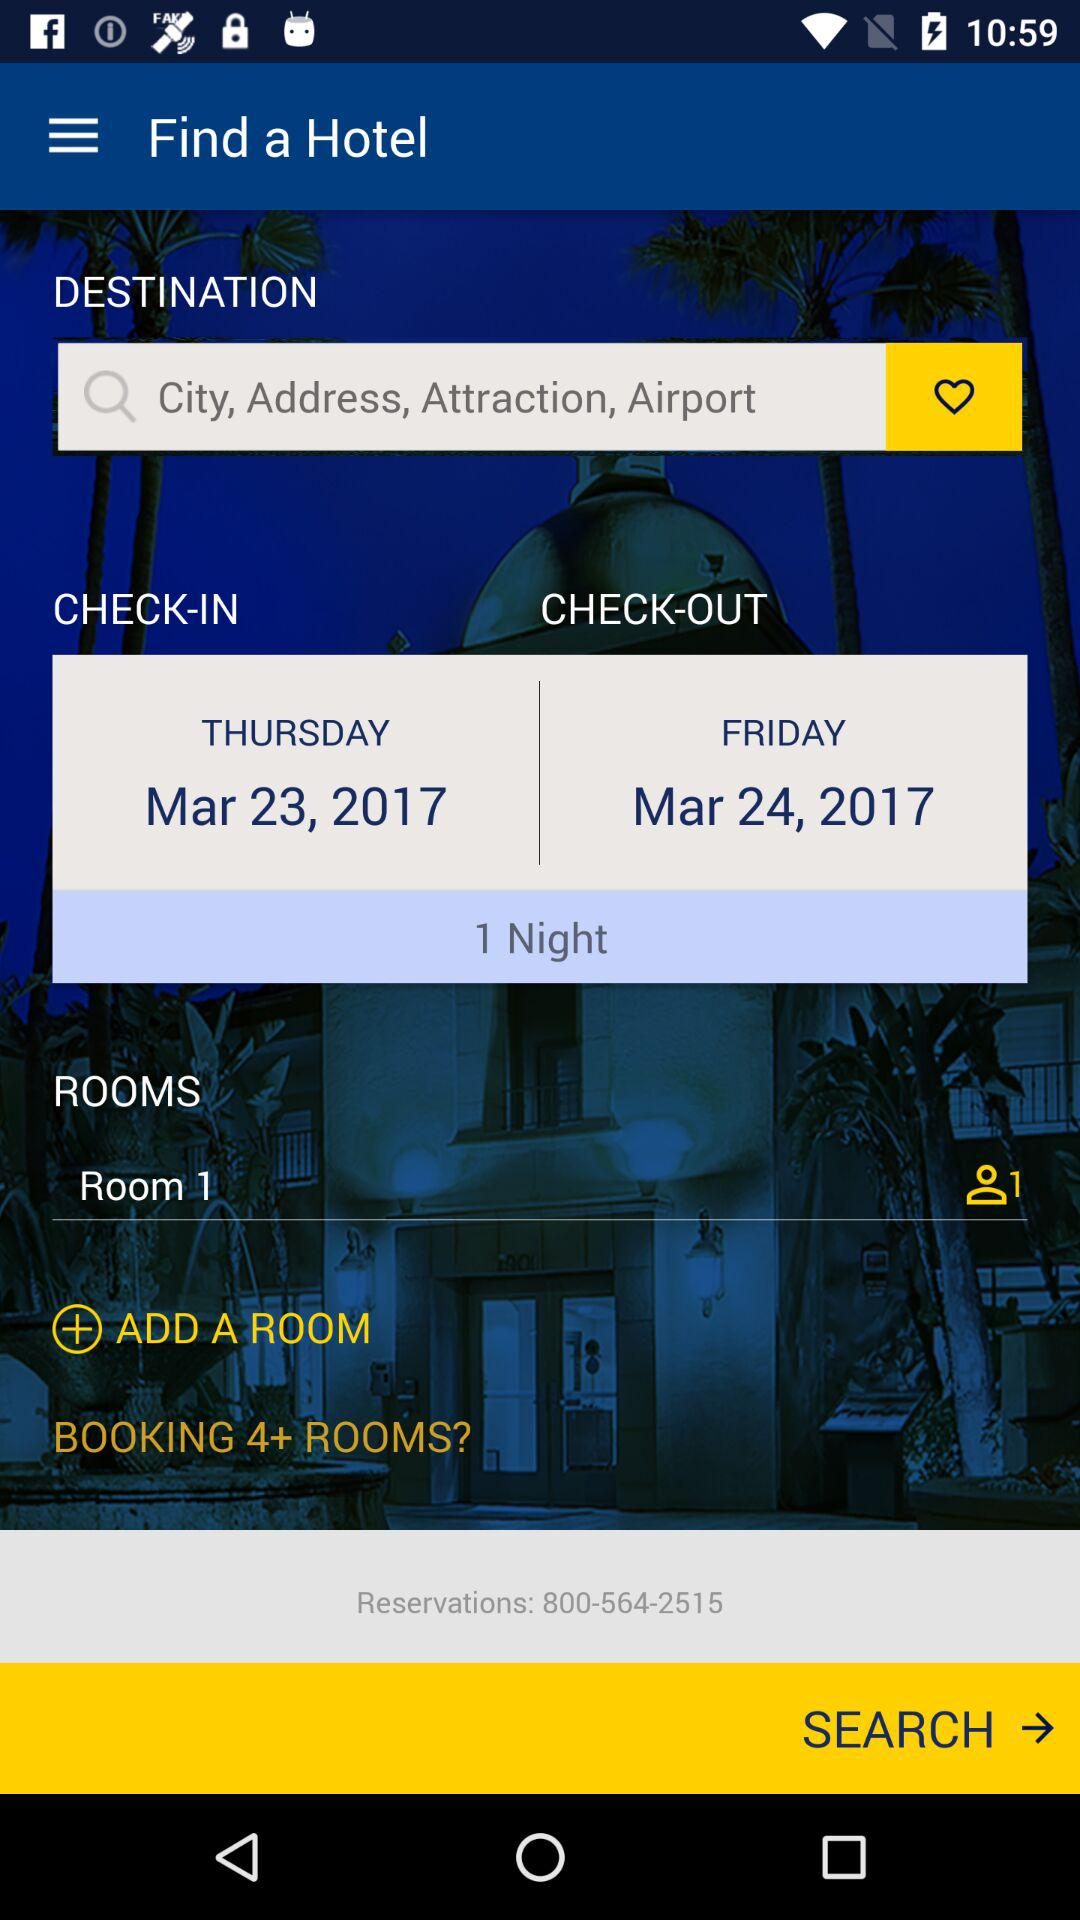What is the duration for staying in a room? The stay in a room is for 1 night. 